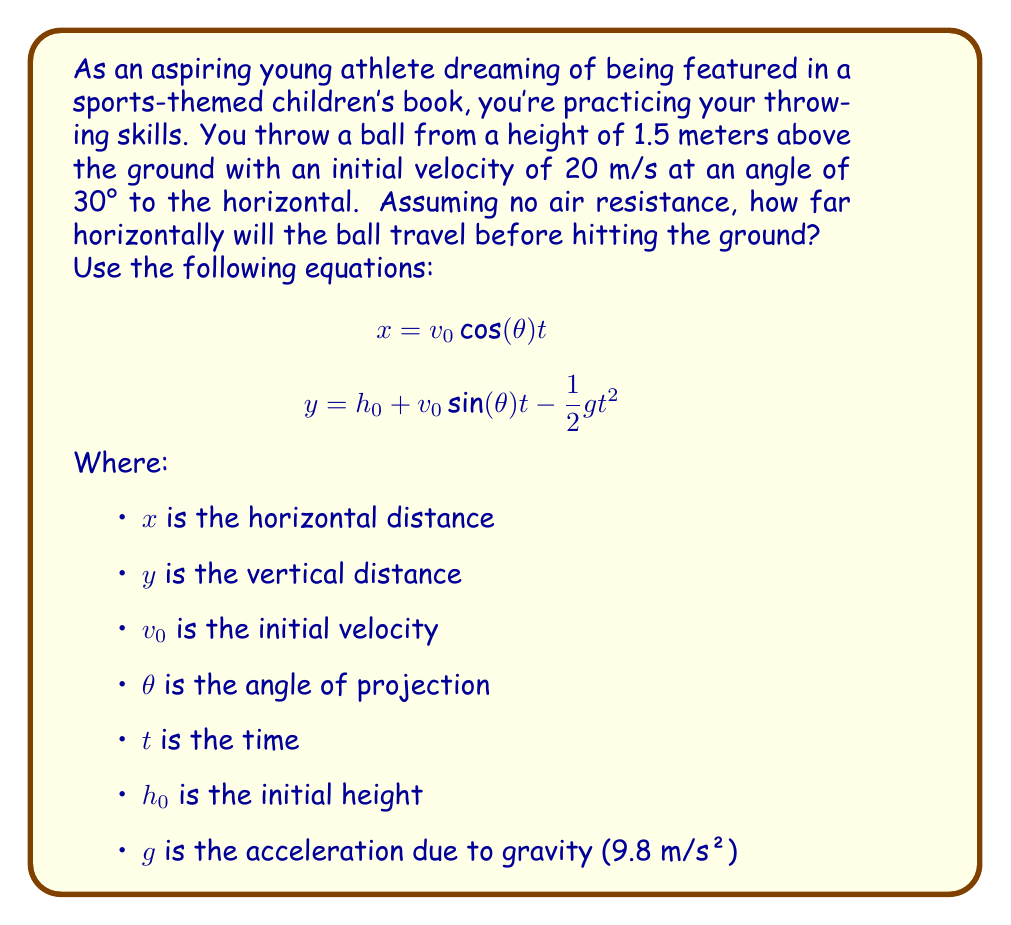Show me your answer to this math problem. To solve this problem, we need to follow these steps:

1) First, we need to find the time it takes for the ball to hit the ground. We can do this using the vertical motion equation:

   $$y = h_0 + v_0 \sin(\theta) t - \frac{1}{2}gt^2$$

   When the ball hits the ground, y = 0. So:

   $$0 = 1.5 + 20 \sin(30°) t - \frac{1}{2}(9.8)t^2$$

2) Simplify:
   $$0 = 1.5 + 10t - 4.9t^2$$

3) This is a quadratic equation. We can solve it using the quadratic formula:

   $$t = \frac{-b \pm \sqrt{b^2 - 4ac}}{2a}$$

   Where $a = -4.9$, $b = 10$, and $c = 1.5$

4) Solving this gives us two solutions: $t ≈ 2.087$ seconds or $t ≈ -0.046$ seconds. We discard the negative time as it's not physically meaningful.

5) Now that we know the time, we can use the horizontal motion equation to find the distance:

   $$x = v_0 \cos(\theta) t$$

6) Plugging in our values:
   $$x = 20 \cos(30°) (2.087)$$

7) Simplify:
   $$x = 20 (0.866) (2.087) ≈ 36.15 \text{ meters}$$

Therefore, the ball will travel approximately 36.15 meters horizontally before hitting the ground.
Answer: 36.15 meters 